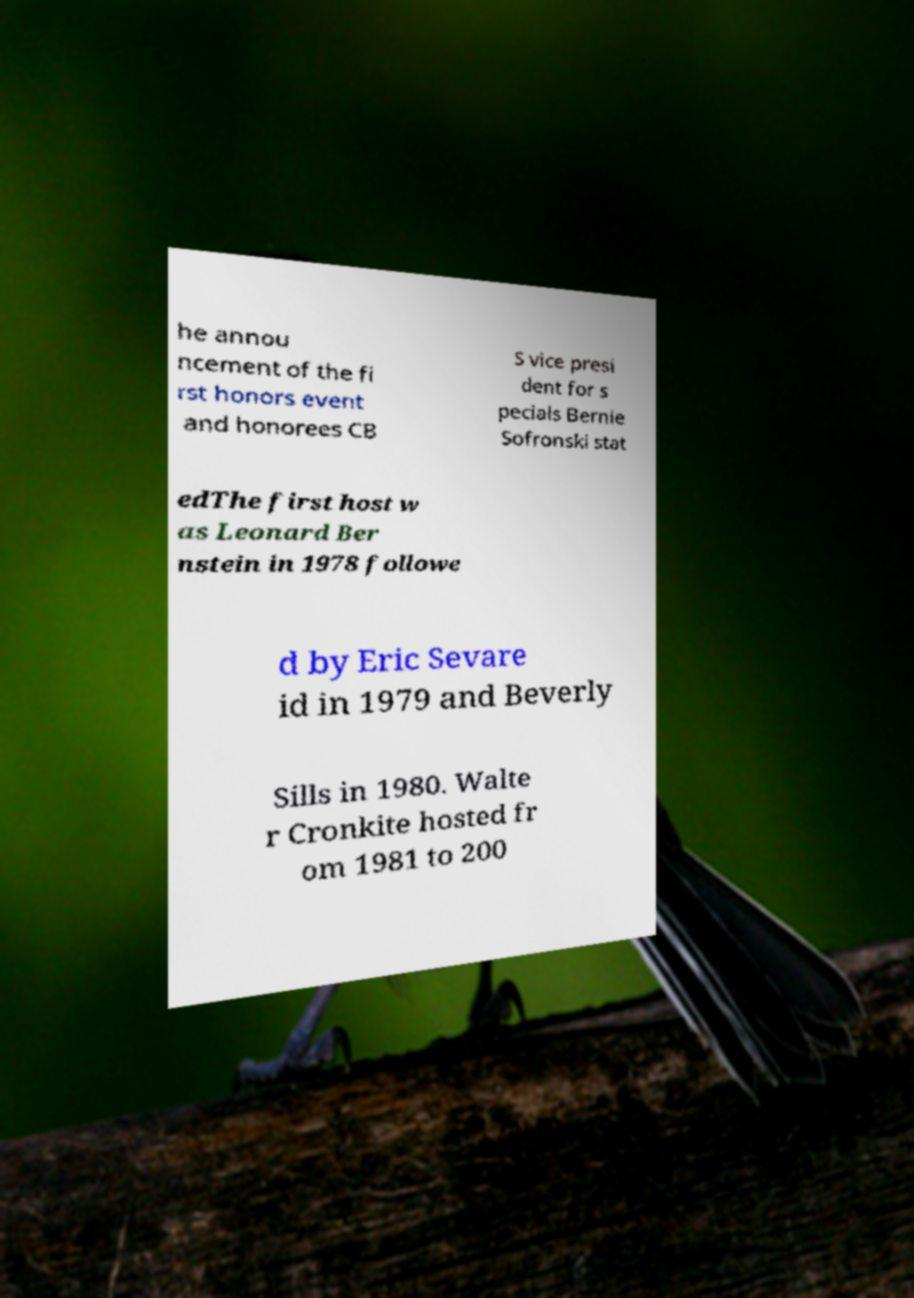I need the written content from this picture converted into text. Can you do that? he annou ncement of the fi rst honors event and honorees CB S vice presi dent for s pecials Bernie Sofronski stat edThe first host w as Leonard Ber nstein in 1978 followe d by Eric Sevare id in 1979 and Beverly Sills in 1980. Walte r Cronkite hosted fr om 1981 to 200 